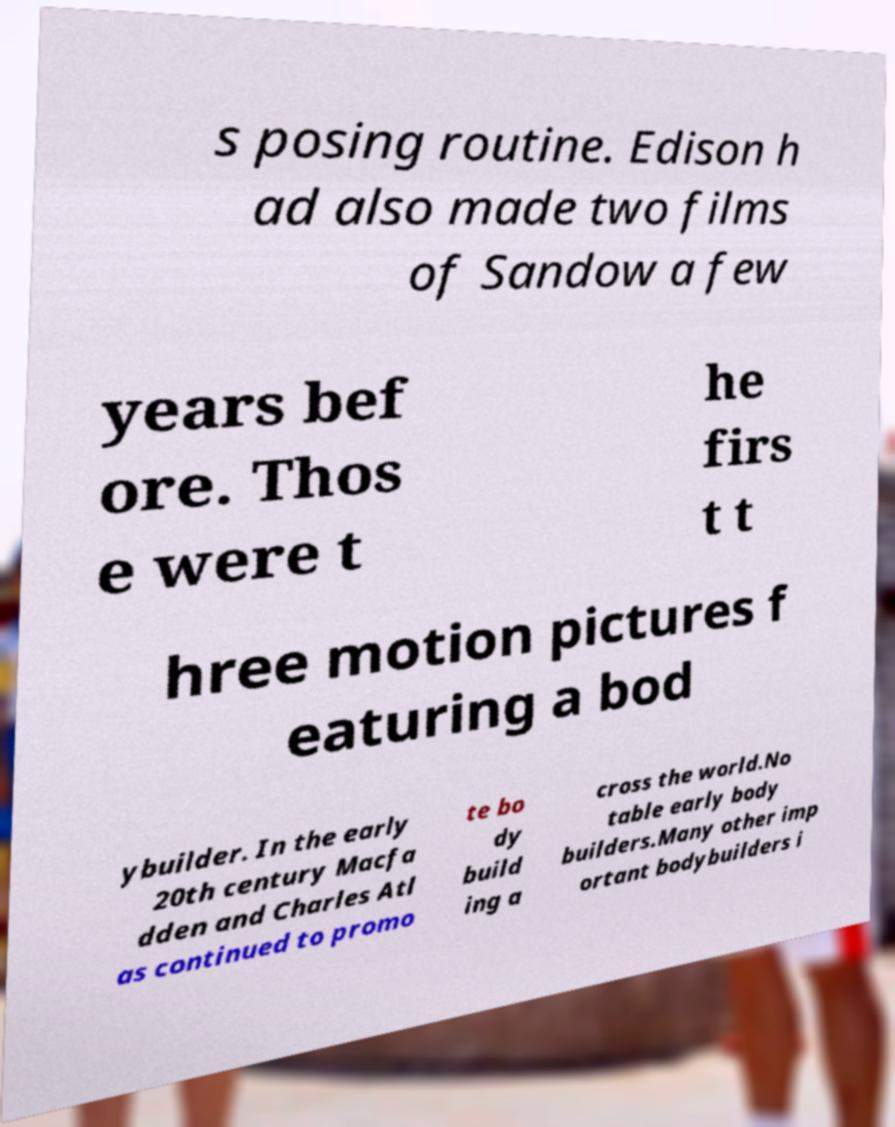Can you accurately transcribe the text from the provided image for me? s posing routine. Edison h ad also made two films of Sandow a few years bef ore. Thos e were t he firs t t hree motion pictures f eaturing a bod ybuilder. In the early 20th century Macfa dden and Charles Atl as continued to promo te bo dy build ing a cross the world.No table early body builders.Many other imp ortant bodybuilders i 